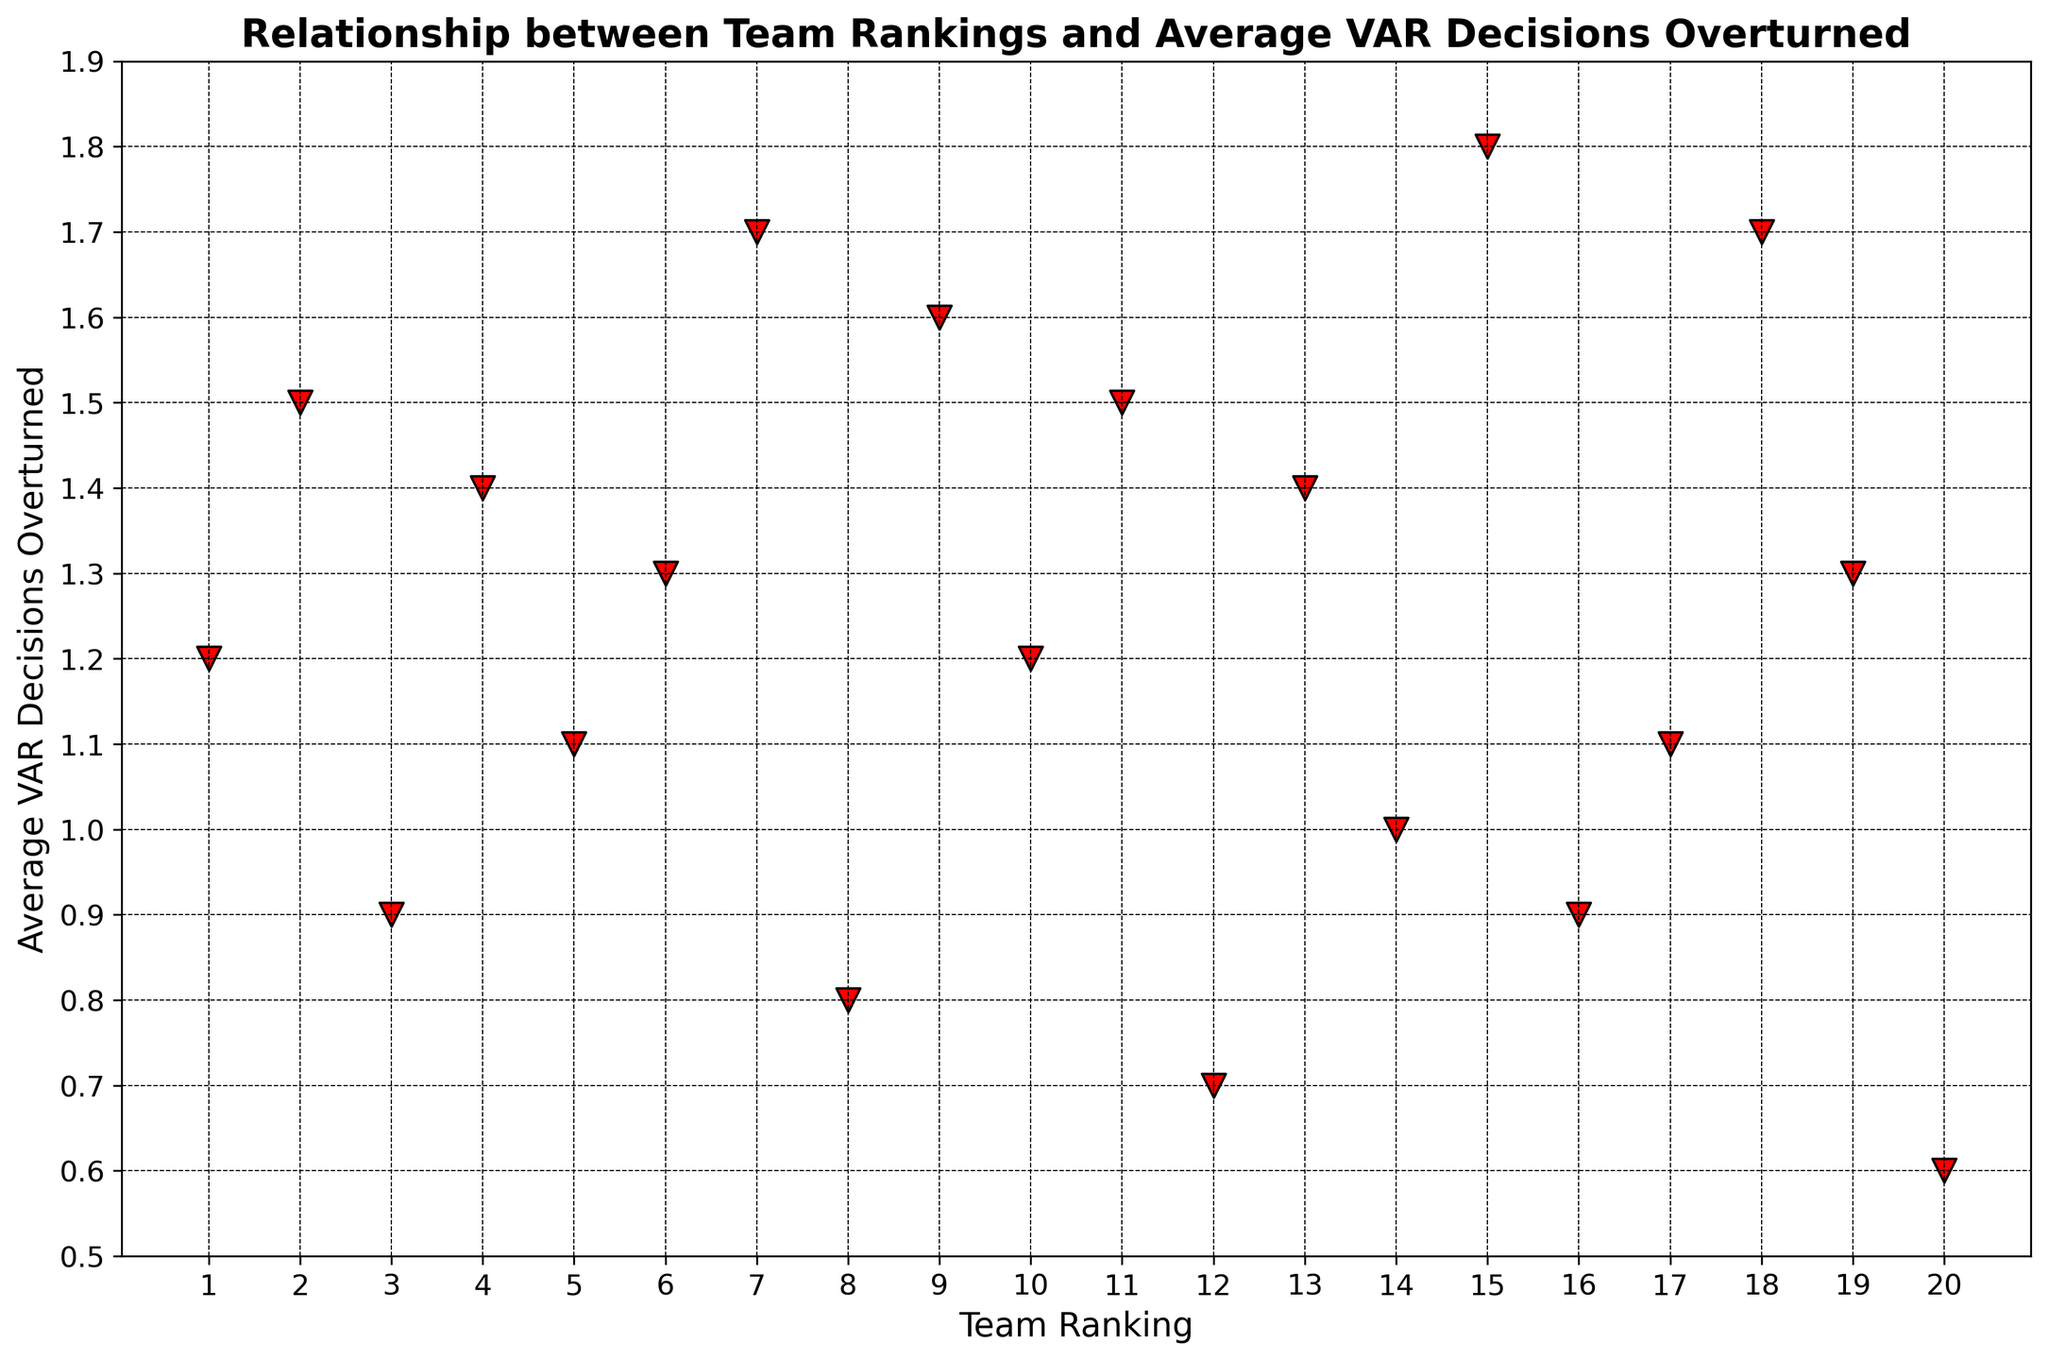What's the highest average VAR decisions overturned for any team ranking? From the scatter plot, we observe the data points corresponding to the highest vertical value on the y-axis, which is around 1.8
Answer: 1.8 Which team ranking had the lowest average VAR decisions overturned? To identify the team ranking with the lowest average VAR decisions overturned, locate the data point closest to the bottom on the y-axis, which is 0.6
Answer: 20 Are there any team rankings which have the same average VAR decisions overturned? Check for data points with the same vertical position (y-value). Rankings 2 and 11 have the same average VAR decisions overturned of 1.5; similarly, rankings 6 and 19 both have average overturned decisions of 1.3.
Answer: Yes What is the average number of VAR decisions overturned for teams ranked top 10? Identify the points for rankings 1 through 10 on the x-axis, sum their y-values (average VAR decisions overturned), and divide by 10: (1.2 + 1.5 + 0.9 + 1.4 + 1.1 + 1.3 + 1.7 + 0.8 + 1.6 + 1.2) = 12.7; 12.7 / 10 = 1.27
Answer: 1.27 Which team ranking had an average VAR decisions overturned closest to 1.0? Find the data point on the scatter plot closest to the y-value of 1.0. In this case, team rankings 14 and 3 (less precisely ranking 14) are closest to 1.0
Answer: 14 Is there a general trend or correlation between team ranking and average VAR decisions overturned? Look at whether higher-ranked teams (lower x-values) have different average VAR decisions overturned compared to lower-ranked teams (higher x-values). While no strong trend is seen, there is a slight variation as teams with different rankings have varying values of overturned decisions.
Answer: No clear trend What is the difference in the average VAR decisions overturned between team rankings 1 and 15? Identify the y-values for team rankings 1 and 15, then subtract: 1.8 (rank 15) - 1.2 (rank 1) = 0.6
Answer: 0.6 Which has a higher average VAR decisions overturned, team ranking 8 or team ranking 12? Compare the y-values for rankings 8 and 12; 8 has 0.8 while 12 has 0.7
Answer: Team ranking 8 For team ranking 9, how does its average VAR decisions overturned compare to the average of the entire dataset? First calculate the dataset's average: (sum of all y-values)/20 = 1.19. Then compare this to the y-value for rank 9, which is 1.6. 1.6 is greater than 1.19.
Answer: Higher 